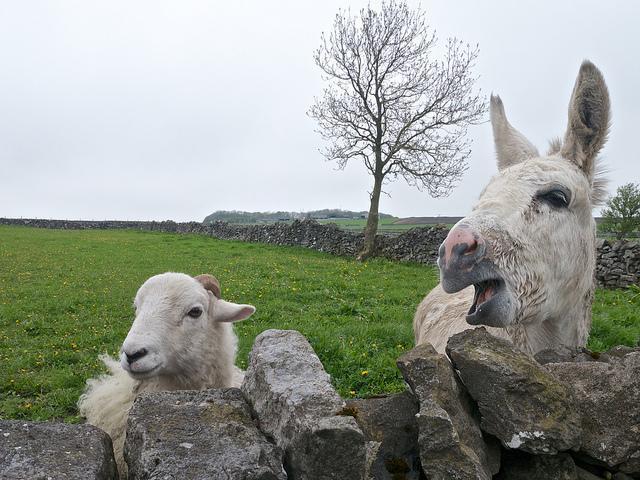How many trees are there?
Give a very brief answer. 2. How many animals are in the picture?
Give a very brief answer. 2. 